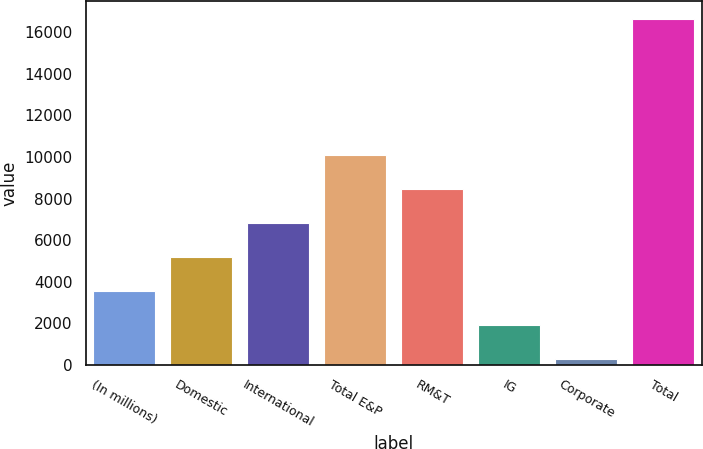<chart> <loc_0><loc_0><loc_500><loc_500><bar_chart><fcel>(In millions)<fcel>Domestic<fcel>International<fcel>Total E&P<fcel>RM&T<fcel>IG<fcel>Corporate<fcel>Total<nl><fcel>3577<fcel>5211.5<fcel>6846<fcel>10115<fcel>8480.5<fcel>1942.5<fcel>308<fcel>16653<nl></chart> 